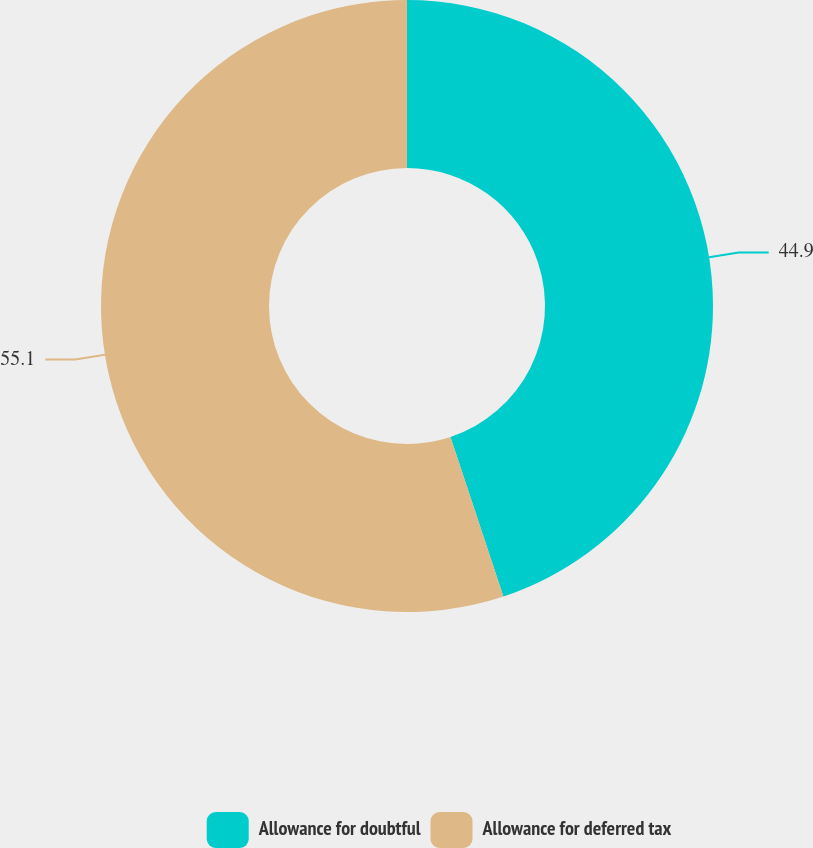Convert chart to OTSL. <chart><loc_0><loc_0><loc_500><loc_500><pie_chart><fcel>Allowance for doubtful<fcel>Allowance for deferred tax<nl><fcel>44.9%<fcel>55.1%<nl></chart> 